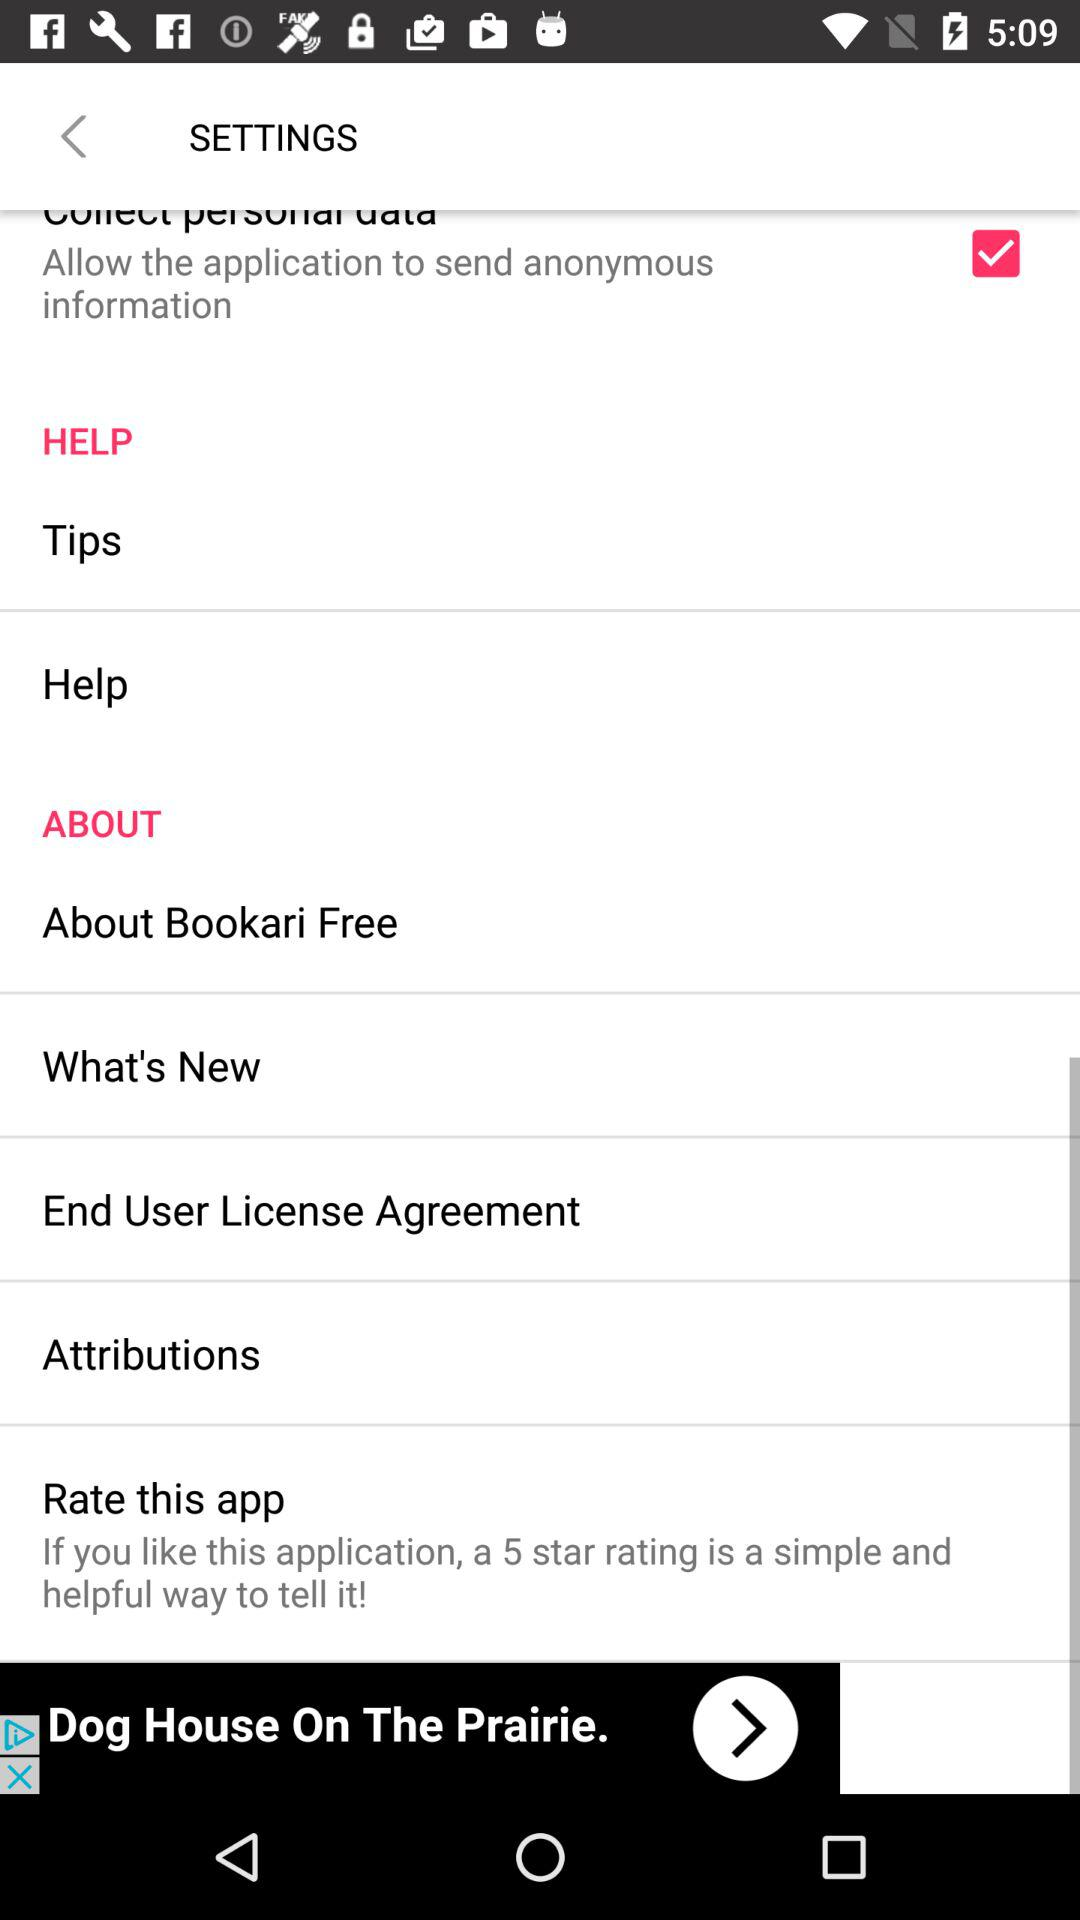What's the status of "Collect personal data"? The status is on. 